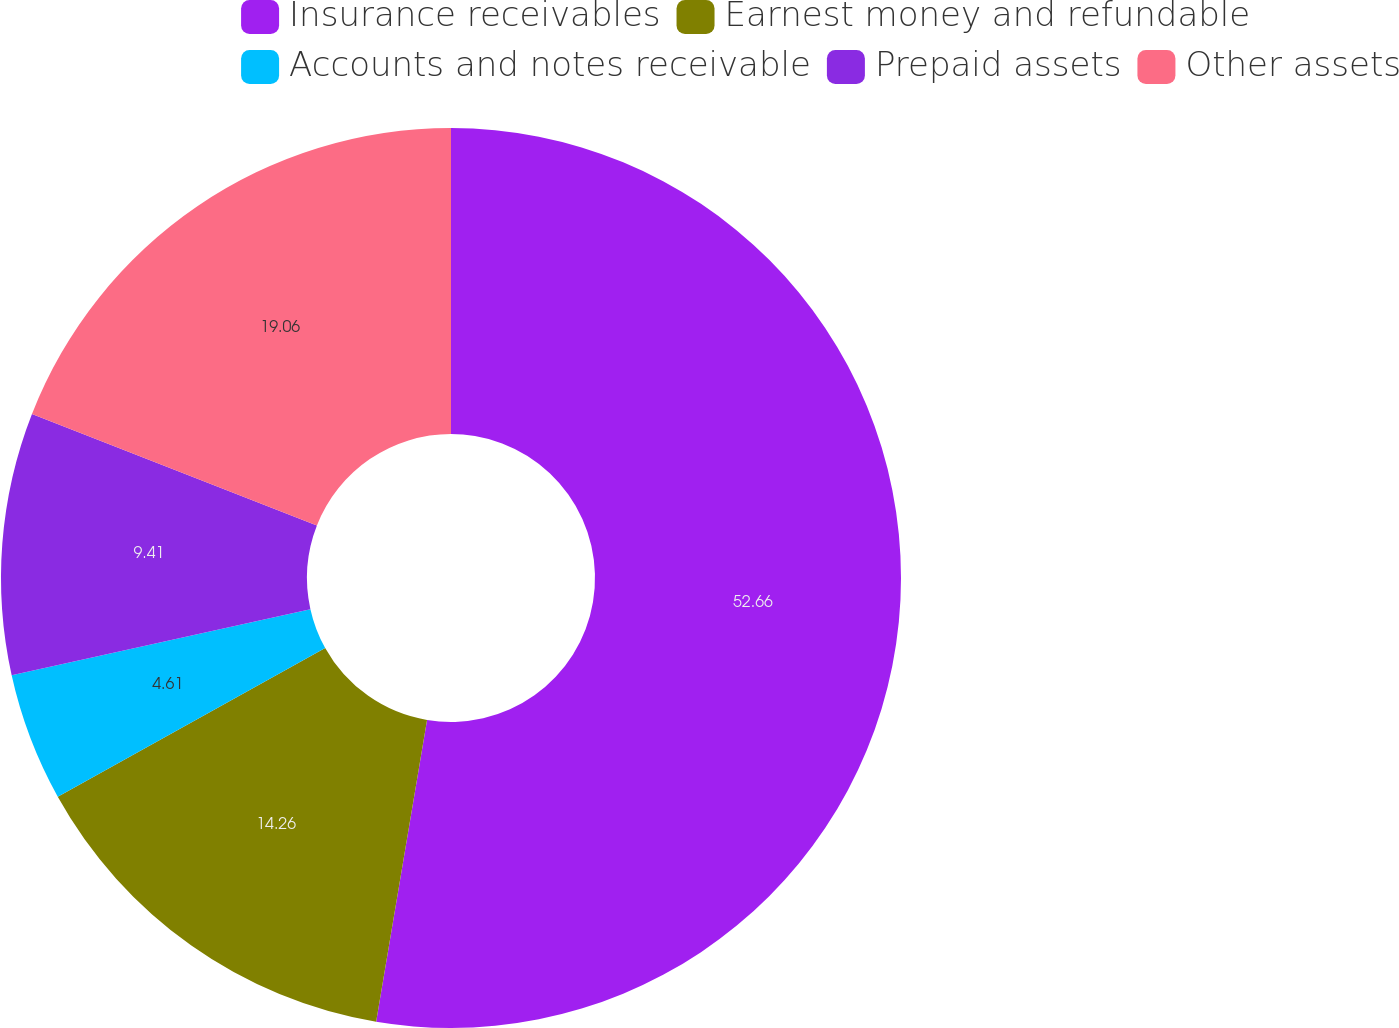<chart> <loc_0><loc_0><loc_500><loc_500><pie_chart><fcel>Insurance receivables<fcel>Earnest money and refundable<fcel>Accounts and notes receivable<fcel>Prepaid assets<fcel>Other assets<nl><fcel>52.66%<fcel>14.26%<fcel>4.61%<fcel>9.41%<fcel>19.06%<nl></chart> 